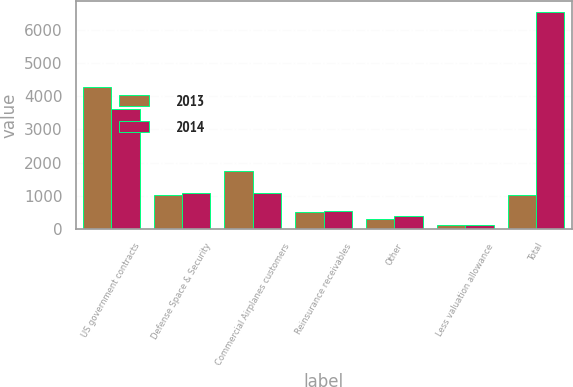Convert chart. <chart><loc_0><loc_0><loc_500><loc_500><stacked_bar_chart><ecel><fcel>US government contracts<fcel>Defense Space & Security<fcel>Commercial Airplanes customers<fcel>Reinsurance receivables<fcel>Other<fcel>Less valuation allowance<fcel>Total<nl><fcel>2013<fcel>4281<fcel>1018<fcel>1749<fcel>512<fcel>296<fcel>127<fcel>1018<nl><fcel>2014<fcel>3604<fcel>1073<fcel>1072<fcel>525<fcel>376<fcel>104<fcel>6546<nl></chart> 